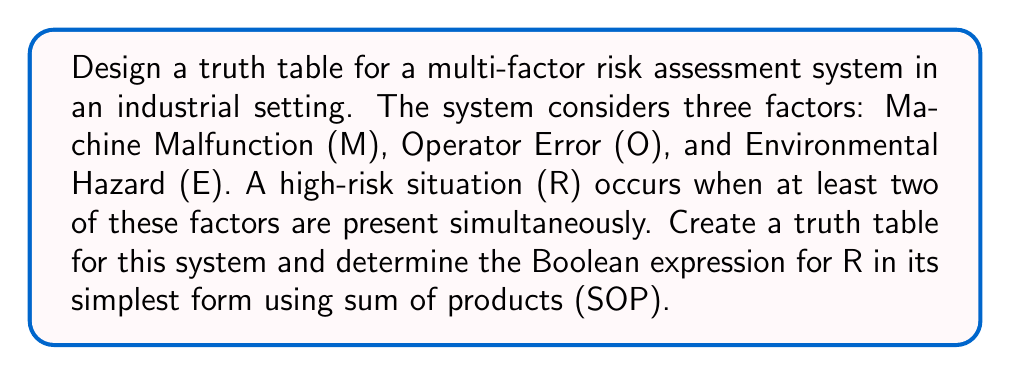Give your solution to this math problem. Let's approach this step-by-step:

1) First, we need to create a truth table with all possible combinations of M, O, and E:

   M | O | E | R
   ---------------
   0 | 0 | 0 | 0
   0 | 0 | 1 | 0
   0 | 1 | 0 | 0
   0 | 1 | 1 | 1
   1 | 0 | 0 | 0
   1 | 0 | 1 | 1
   1 | 1 | 0 | 1
   1 | 1 | 1 | 1

2) Now, we identify the minterms (where R = 1):
   R = 1 when (M,O,E) is (0,1,1), (1,0,1), (1,1,0), or (1,1,1)

3) We can write the SOP expression using these minterms:
   $$R = \bar{M}OE + M\bar{O}E + MO\bar{E} + MOE$$

4) To simplify this expression, we can use Boolean algebra laws:
   $$R = \bar{M}OE + M\bar{O}E + MO\bar{E} + MOE$$
   $$= \bar{M}OE + ME(O + \bar{O}) + MO(\bar{E} + E)$$
   $$= \bar{M}OE + ME + MO$$

5) This is the simplest SOP form for R.

The Boolean expression $$R = \bar{M}OE + ME + MO$$ represents the conditions for a high-risk situation in this industrial setting.
Answer: $$R = \bar{M}OE + ME + MO$$ 